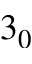Convert formula to latex. <formula><loc_0><loc_0><loc_500><loc_500>3 _ { 0 }</formula> 